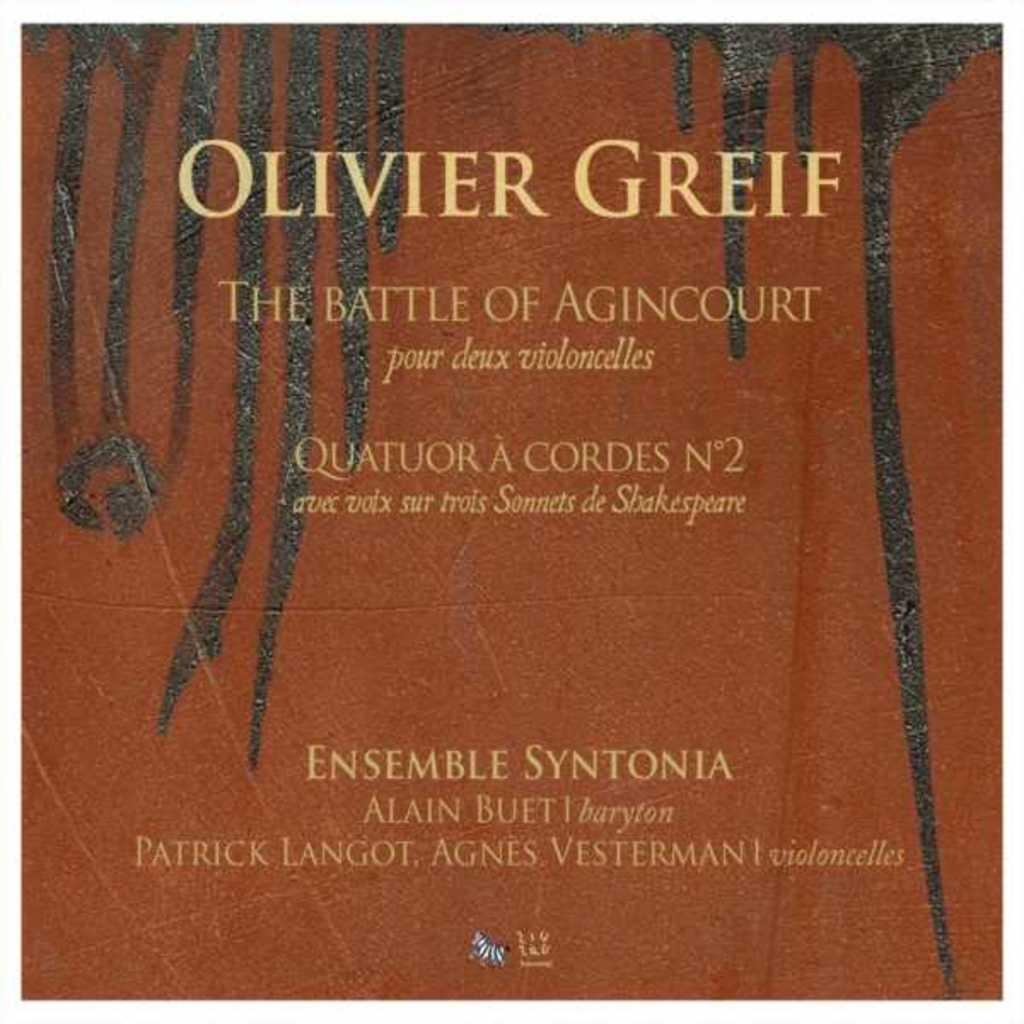<image>
Describe the image concisely. The book her is called The Battle of Agincourt and is written by Olivier Grief 